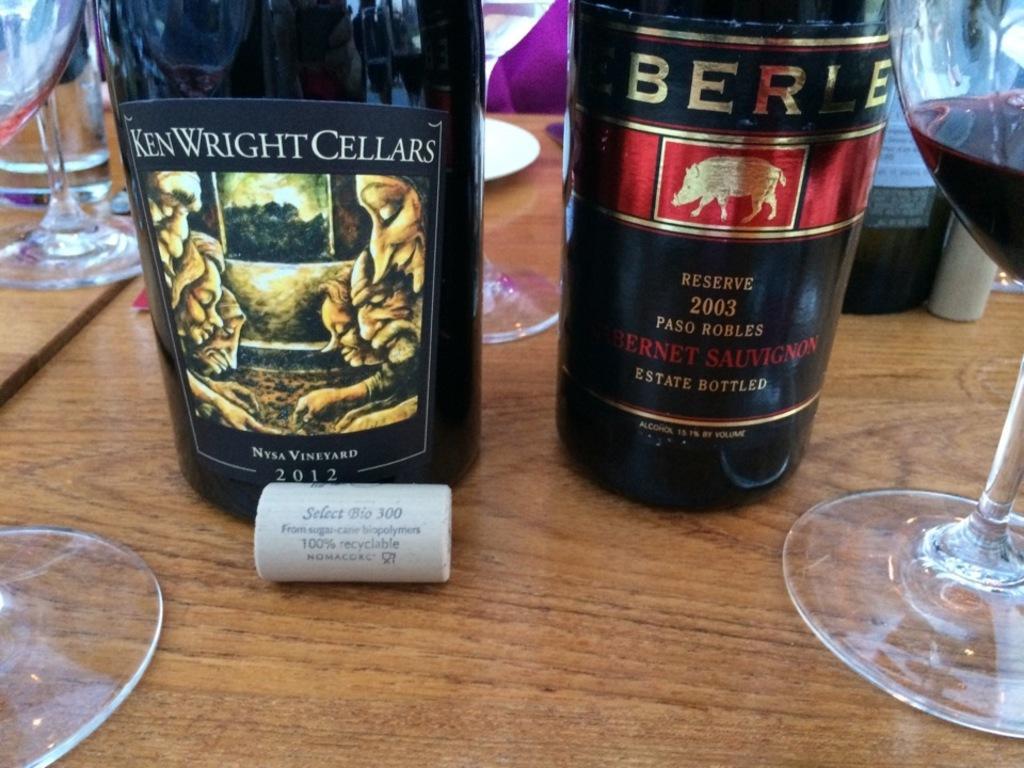Please provide a concise description of this image. In this picture, we see a brown table on which two glass bottles, glass containing wine, glasses, water glass, white plate and a box are placed. 